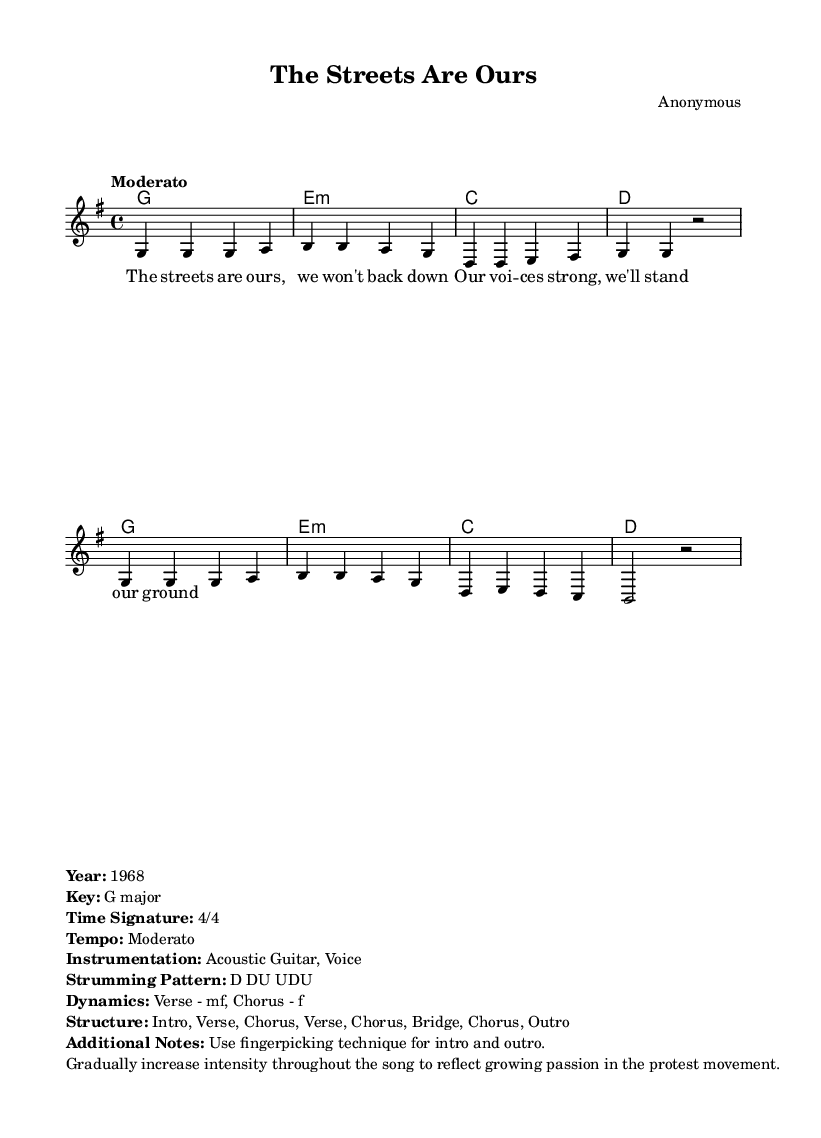What is the key signature of this music? The key signature is G major, which has one sharp. This is indicated in the global declaration of the music sheet.
Answer: G major What is the time signature of this music? The time signature is 4/4, which means there are four beats in each measure. This is shown in the global declaration as well.
Answer: 4/4 What is the tempo marking of the song? The tempo marking is "Moderato," indicating a moderate speed. This is noted in the global section of the music sheet.
Answer: Moderato How many measures are in the verse section? The verse consists of two groups of measures, each having two lines of four measures, totaling 4 measures for the verse. This can be determined by counting the measures in the melody section.
Answer: 4 What instrumentation is used in this piece? The instrumentation indicated is Acoustic Guitar and Voice. This is provided in the markup section that gives additional details about the piece.
Answer: Acoustic Guitar, Voice Which dynamics are prescribed for the chorus? The dynamics for the chorus are indicated as "f," which means forte, suggesting a loud and powerful expression. This is included in the markup section where dynamics are specified.
Answer: f What is the strumming pattern for the song? The strumming pattern is indicated as D DU UDU. This is part of the additional notes in the markup section, specifying how the guitar should be played.
Answer: D DU UDU 